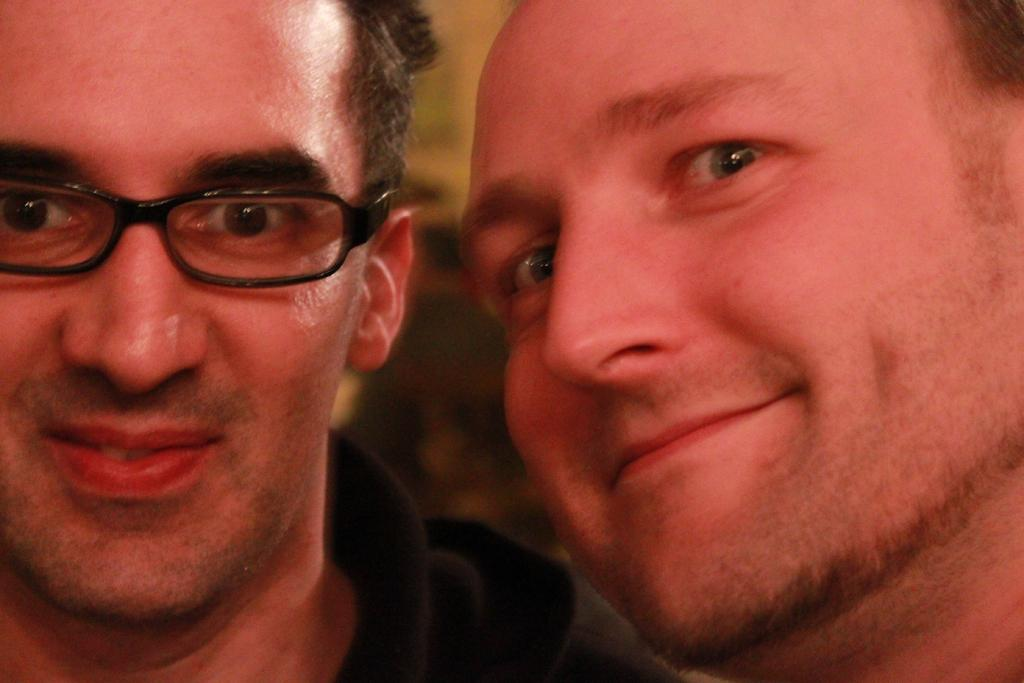How many men are present in the image? There are two men in the image. Can you describe the facial expression of one of the men? One of the men is smiling. What can be seen on the face of one of the men? One of the men is wearing spectacles. What type of bears can be seen playing with the trucks in the image? There are no bears or trucks present in the image. 